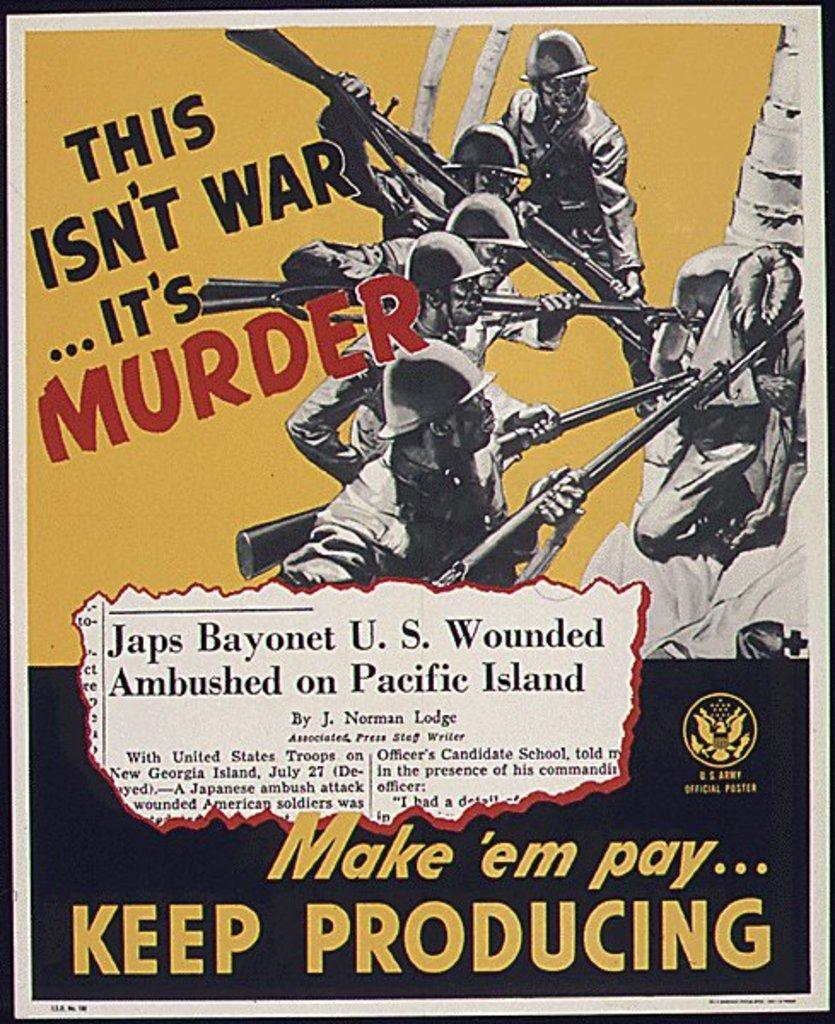<image>
Provide a brief description of the given image. U.S. Army Official Poster of 5 Japanese soldiers bayoneting a U.S. wounded soldier. 